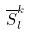<formula> <loc_0><loc_0><loc_500><loc_500>\overline { S } _ { l } ^ { k }</formula> 